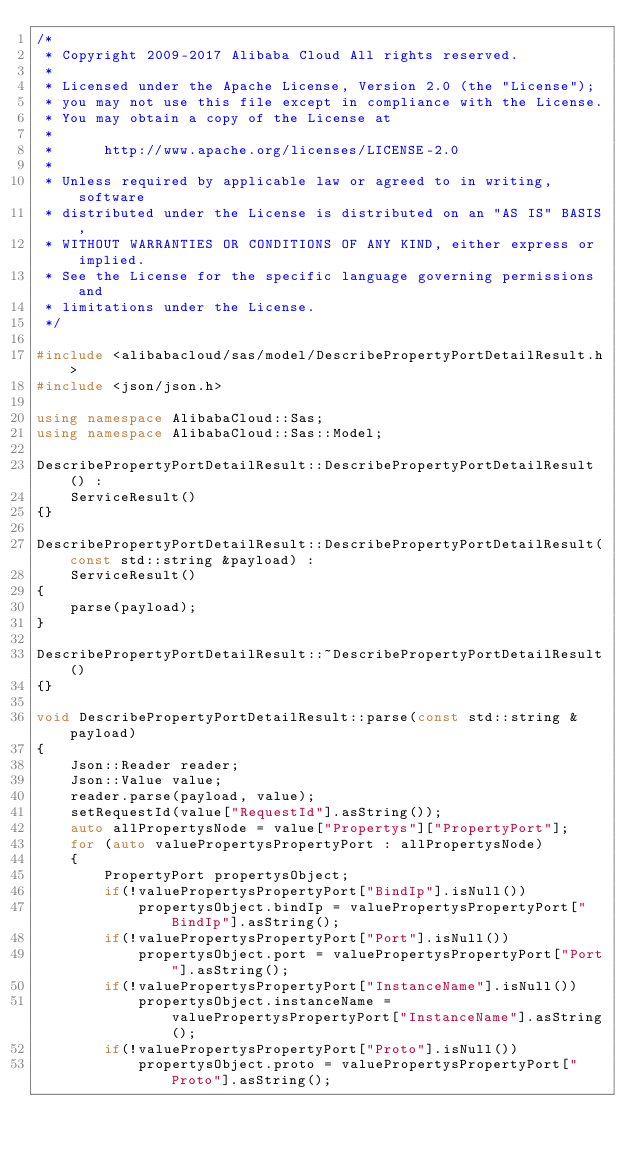<code> <loc_0><loc_0><loc_500><loc_500><_C++_>/*
 * Copyright 2009-2017 Alibaba Cloud All rights reserved.
 * 
 * Licensed under the Apache License, Version 2.0 (the "License");
 * you may not use this file except in compliance with the License.
 * You may obtain a copy of the License at
 * 
 *      http://www.apache.org/licenses/LICENSE-2.0
 * 
 * Unless required by applicable law or agreed to in writing, software
 * distributed under the License is distributed on an "AS IS" BASIS,
 * WITHOUT WARRANTIES OR CONDITIONS OF ANY KIND, either express or implied.
 * See the License for the specific language governing permissions and
 * limitations under the License.
 */

#include <alibabacloud/sas/model/DescribePropertyPortDetailResult.h>
#include <json/json.h>

using namespace AlibabaCloud::Sas;
using namespace AlibabaCloud::Sas::Model;

DescribePropertyPortDetailResult::DescribePropertyPortDetailResult() :
	ServiceResult()
{}

DescribePropertyPortDetailResult::DescribePropertyPortDetailResult(const std::string &payload) :
	ServiceResult()
{
	parse(payload);
}

DescribePropertyPortDetailResult::~DescribePropertyPortDetailResult()
{}

void DescribePropertyPortDetailResult::parse(const std::string &payload)
{
	Json::Reader reader;
	Json::Value value;
	reader.parse(payload, value);
	setRequestId(value["RequestId"].asString());
	auto allPropertysNode = value["Propertys"]["PropertyPort"];
	for (auto valuePropertysPropertyPort : allPropertysNode)
	{
		PropertyPort propertysObject;
		if(!valuePropertysPropertyPort["BindIp"].isNull())
			propertysObject.bindIp = valuePropertysPropertyPort["BindIp"].asString();
		if(!valuePropertysPropertyPort["Port"].isNull())
			propertysObject.port = valuePropertysPropertyPort["Port"].asString();
		if(!valuePropertysPropertyPort["InstanceName"].isNull())
			propertysObject.instanceName = valuePropertysPropertyPort["InstanceName"].asString();
		if(!valuePropertysPropertyPort["Proto"].isNull())
			propertysObject.proto = valuePropertysPropertyPort["Proto"].asString();</code> 